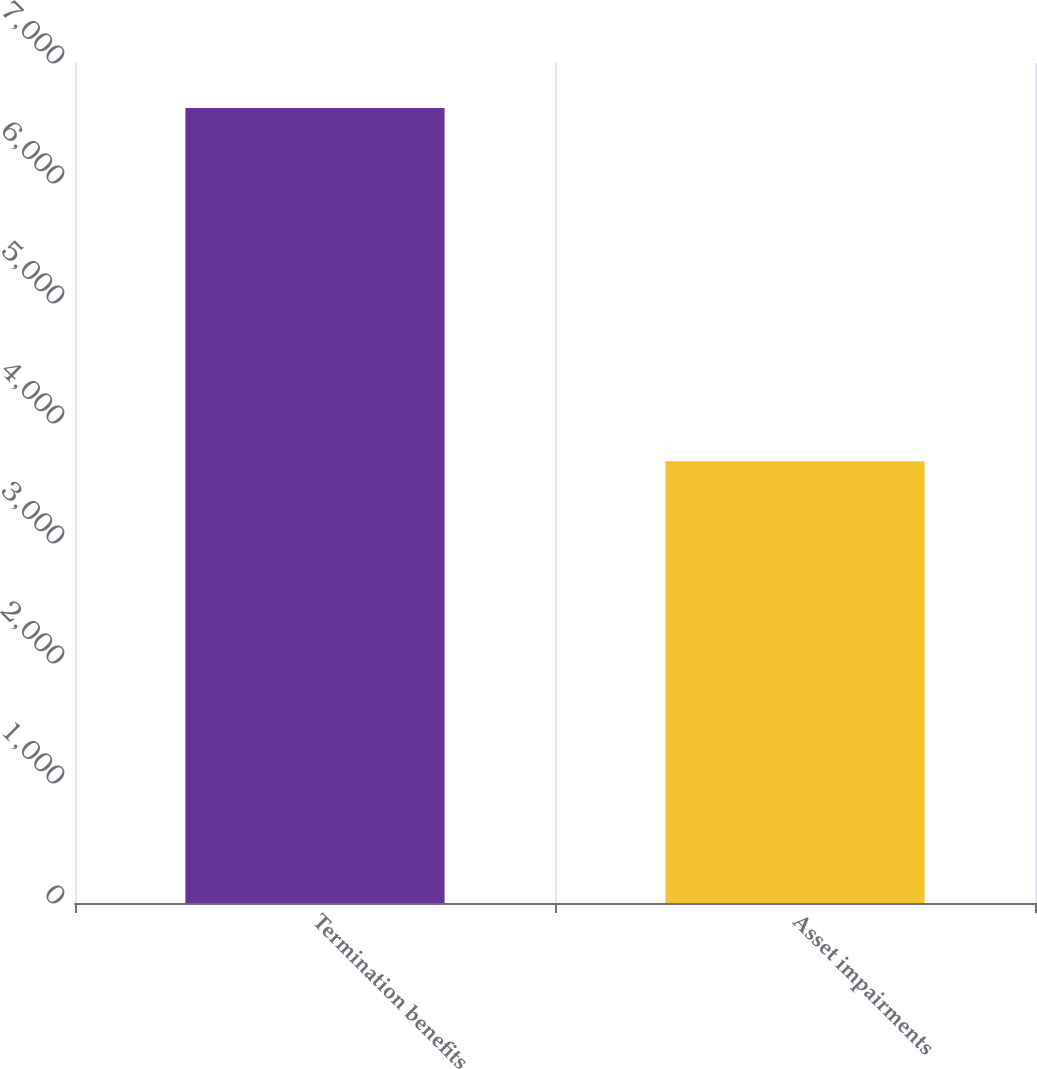<chart> <loc_0><loc_0><loc_500><loc_500><bar_chart><fcel>Termination benefits<fcel>Asset impairments<nl><fcel>6625<fcel>3681<nl></chart> 